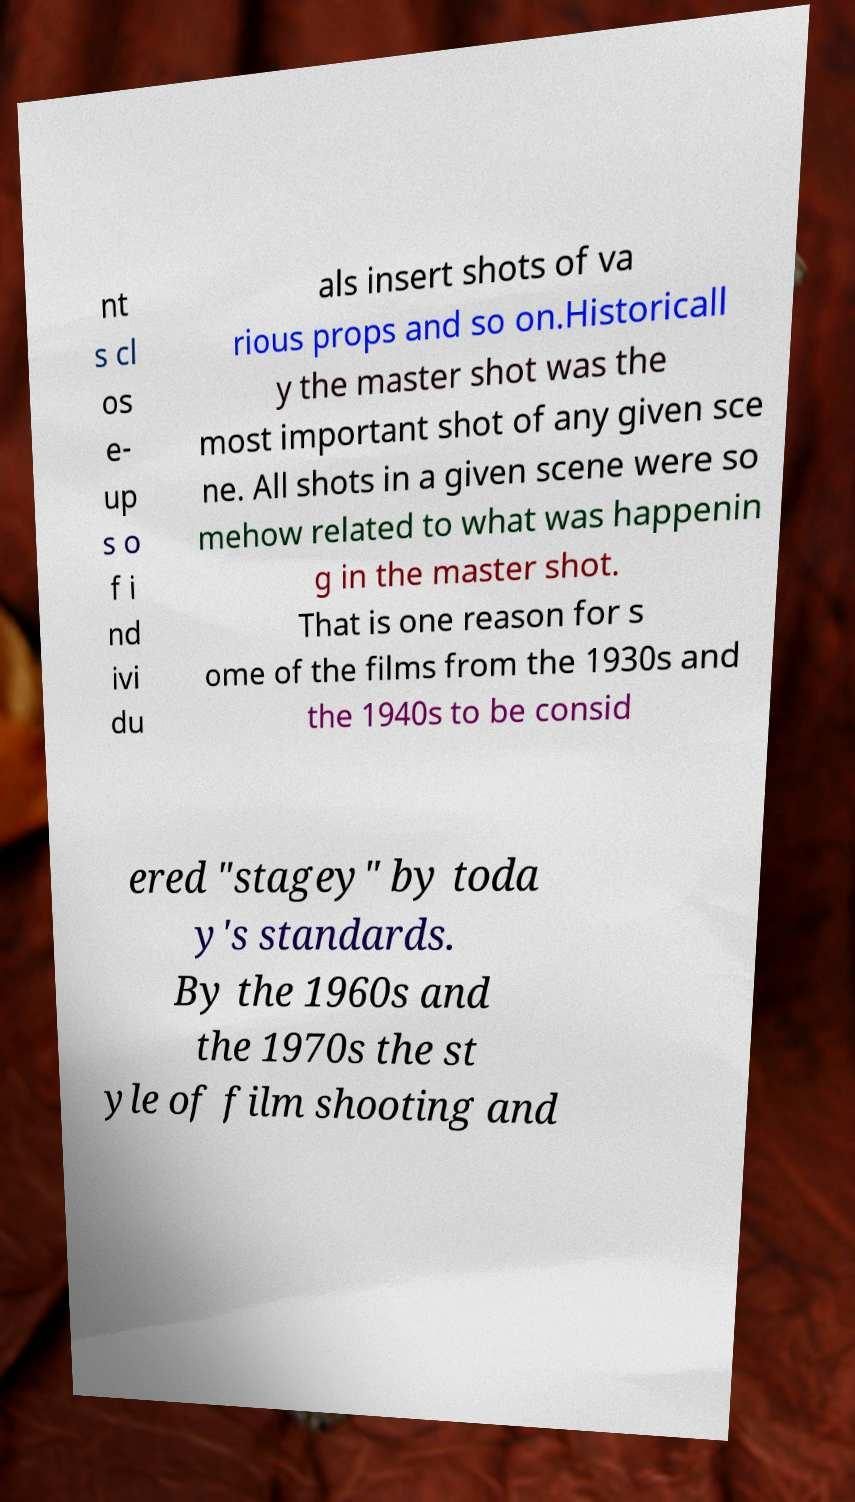I need the written content from this picture converted into text. Can you do that? nt s cl os e- up s o f i nd ivi du als insert shots of va rious props and so on.Historicall y the master shot was the most important shot of any given sce ne. All shots in a given scene were so mehow related to what was happenin g in the master shot. That is one reason for s ome of the films from the 1930s and the 1940s to be consid ered "stagey" by toda y's standards. By the 1960s and the 1970s the st yle of film shooting and 